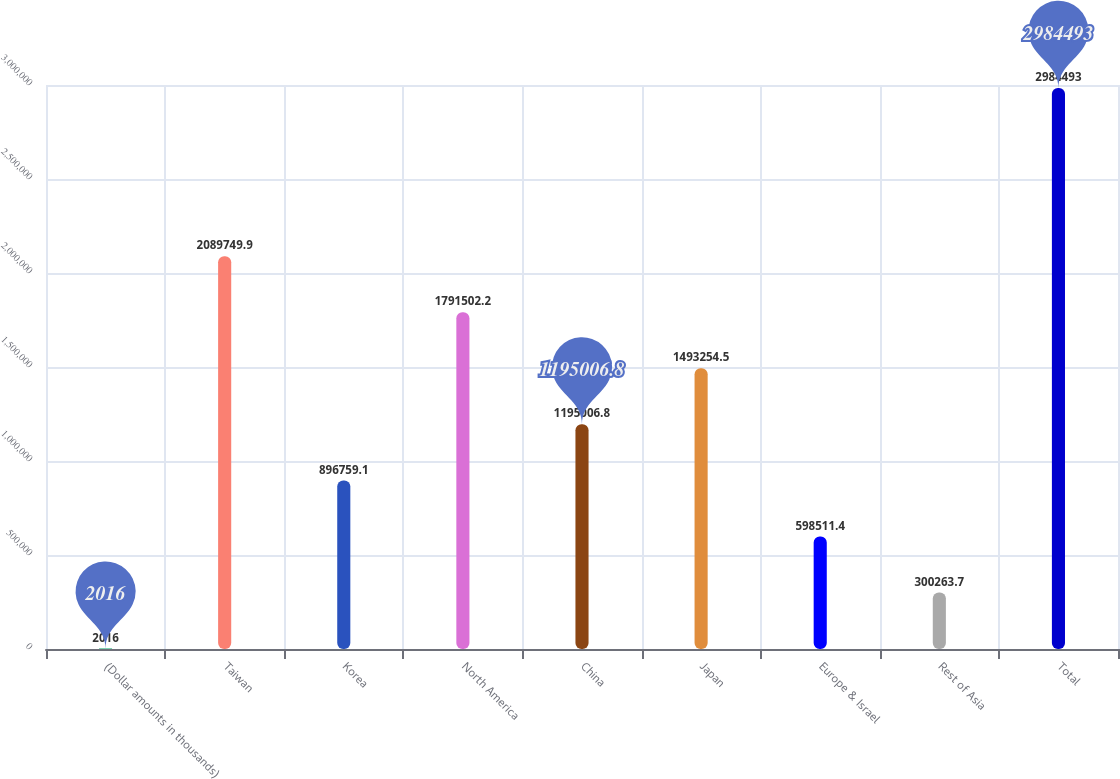<chart> <loc_0><loc_0><loc_500><loc_500><bar_chart><fcel>(Dollar amounts in thousands)<fcel>Taiwan<fcel>Korea<fcel>North America<fcel>China<fcel>Japan<fcel>Europe & Israel<fcel>Rest of Asia<fcel>Total<nl><fcel>2016<fcel>2.08975e+06<fcel>896759<fcel>1.7915e+06<fcel>1.19501e+06<fcel>1.49325e+06<fcel>598511<fcel>300264<fcel>2.98449e+06<nl></chart> 